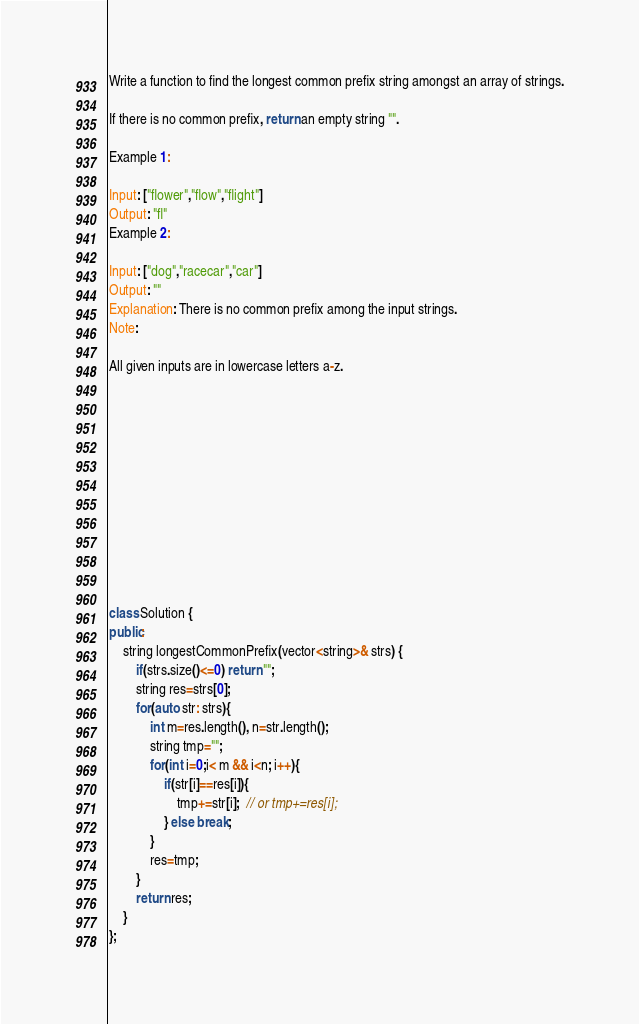Convert code to text. <code><loc_0><loc_0><loc_500><loc_500><_C++_>Write a function to find the longest common prefix string amongst an array of strings.

If there is no common prefix, return an empty string "".

Example 1:

Input: ["flower","flow","flight"]
Output: "fl"
Example 2:

Input: ["dog","racecar","car"]
Output: ""
Explanation: There is no common prefix among the input strings.
Note:

All given inputs are in lowercase letters a-z.












class Solution {
public:
    string longestCommonPrefix(vector<string>& strs) {
        if(strs.size()<=0) return "";
        string res=strs[0];
        for(auto str: strs){
            int m=res.length(), n=str.length();
            string tmp="";
            for(int i=0;i< m && i<n; i++){
                if(str[i]==res[i]){
                    tmp+=str[i];  // or tmp+=res[i];
                } else break;
            }
            res=tmp;
        }
        return res;
    }
};
</code> 